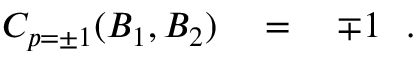Convert formula to latex. <formula><loc_0><loc_0><loc_500><loc_500>C _ { p = \pm 1 } ( B _ { 1 } , B _ { 2 } ) \quad = \quad \mp 1 \ \ .</formula> 